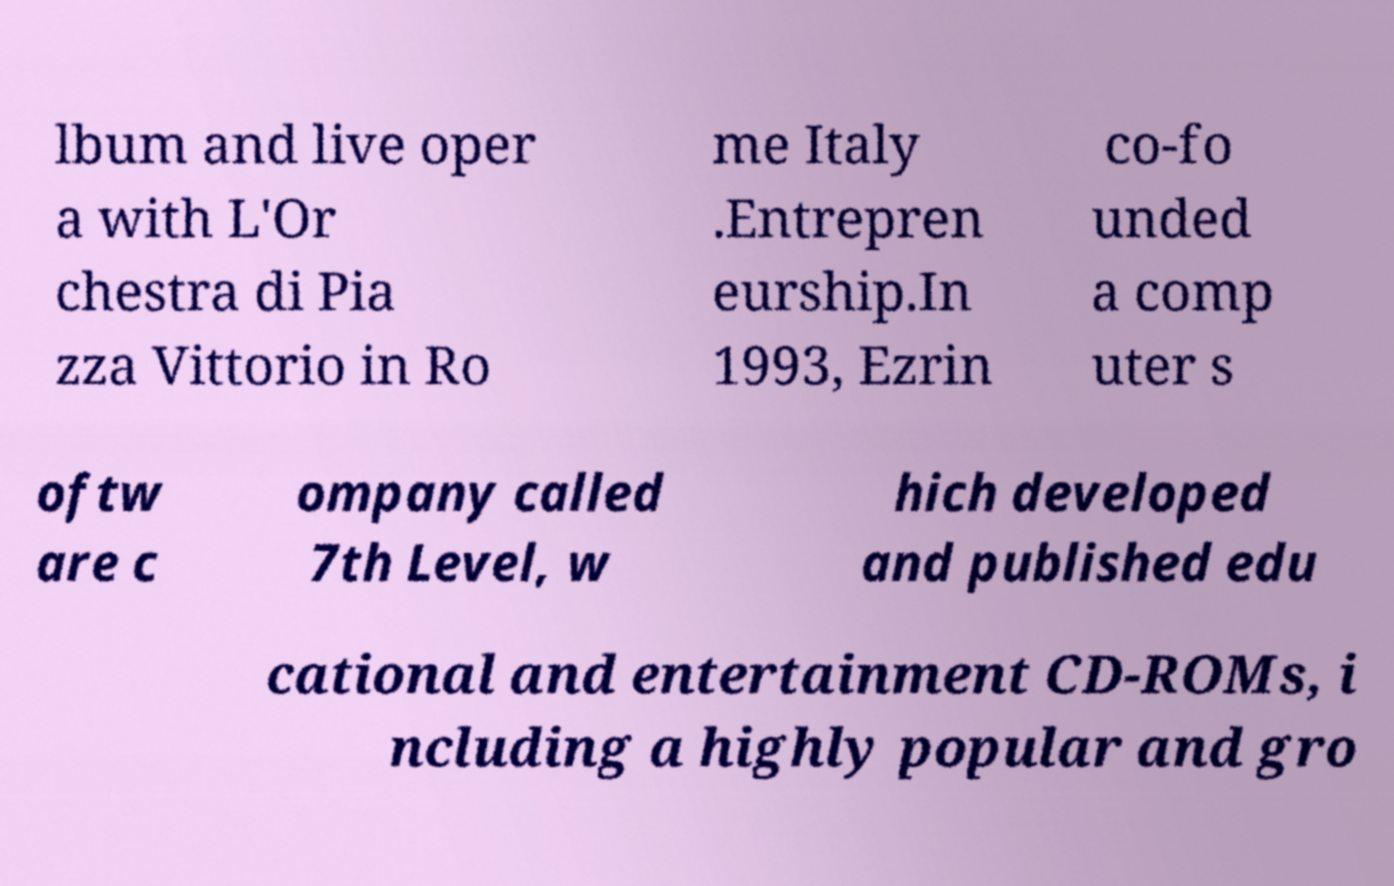Could you extract and type out the text from this image? lbum and live oper a with L'Or chestra di Pia zza Vittorio in Ro me Italy .Entrepren eurship.In 1993, Ezrin co-fo unded a comp uter s oftw are c ompany called 7th Level, w hich developed and published edu cational and entertainment CD-ROMs, i ncluding a highly popular and gro 